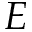Convert formula to latex. <formula><loc_0><loc_0><loc_500><loc_500>E</formula> 